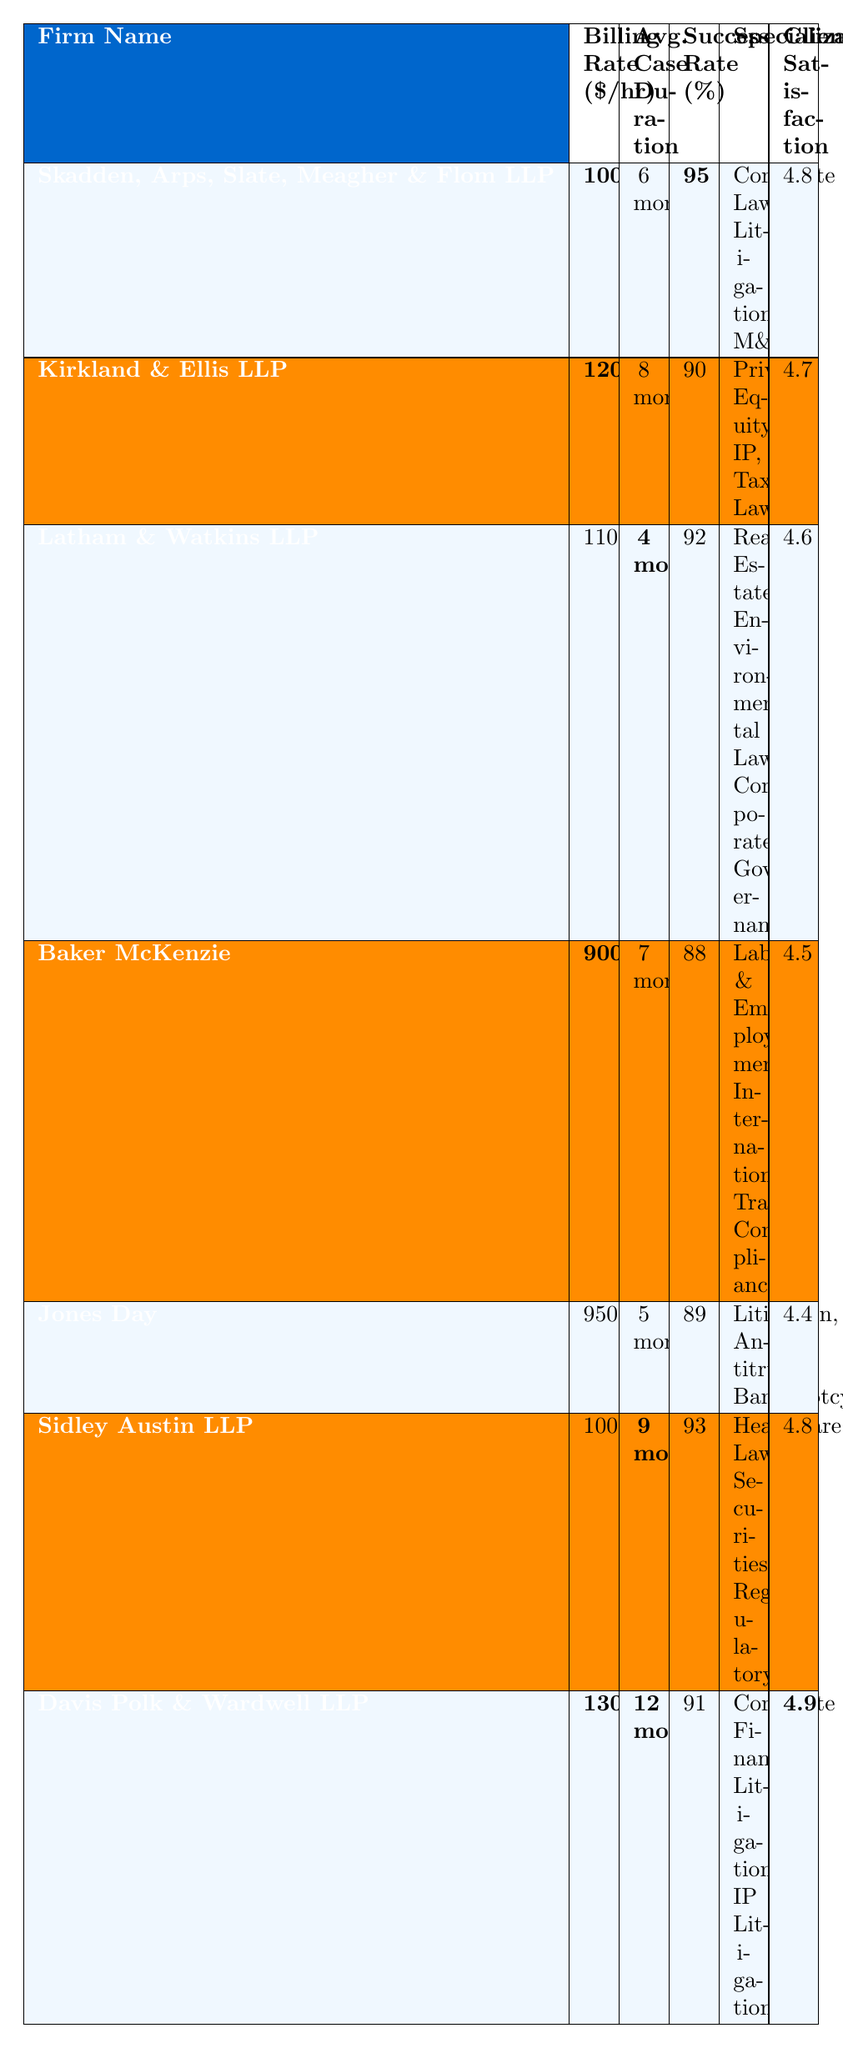What is the billing rate of Sidley Austin LLP? The billing rate for Sidley Austin LLP is listed in the table, and it shows **$1000**.
Answer: 1000 Which firm has the highest success rate? By comparing the success rates of all the firms, we find that **Skadden, Arps, Slate, Meagher & Flom LLP** has the highest success rate at **95%**.
Answer: 95 What is the average case duration for Latham & Watkins LLP? The table indicates that the average case duration for Latham & Watkins LLP is **4 months**.
Answer: 4 months Among the firms, which one has the lowest billing rate? The billing rates are compared, and **Baker McKenzie** has the lowest at **$900/hour**.
Answer: 900 What is the total success rate of the firms that specialize in Corporate Law? The firms specializing in Corporate Law are Skadden, Arps, Slate, Meagher & Flom LLP (95%) and Davis Polk & Wardwell LLP (91%). Summing these gives 95 + 91 = **186**.
Answer: 186 Is the average case duration for Kirkland & Ellis LLP longer than that for Jones Day? Kirkland & Ellis LLP has an average case duration of **8 months**, while Jones Day has **5 months**. Since 8 is greater than 5, the statement is true.
Answer: Yes What is the average client satisfaction of all firms listed? The client satisfaction ratings are as follows: 4.8, 4.7, 4.6, 4.5, 4.4, 4.8, and 4.9. To find the average, we sum them up (4.8 + 4.7 + 4.6 + 4.5 + 4.4 + 4.8 + 4.9 = 33.7) and divide by the total number of firms (7), which is **33.7/7 ≈ 4.81**.
Answer: 4.81 Which law firm has the highest billing rate and what is it? Looking at the billing rates, **Davis Polk & Wardwell LLP** has the highest billing rate at **$1300/hour**.
Answer: 1300 Are there any firms that have a client satisfaction score of 4.9? The data shows that **Davis Polk & Wardwell LLP** has a client satisfaction score of **4.9**, confirming that there is at least one firm with this score.
Answer: Yes What is the difference in billing rates between Kirkland & Ellis LLP and Baker McKenzie? The billing rate for Kirkland & Ellis LLP is **$1200**, and for Baker McKenzie, it is **$900**. The difference is **1200 - 900 = 300**.
Answer: 300 